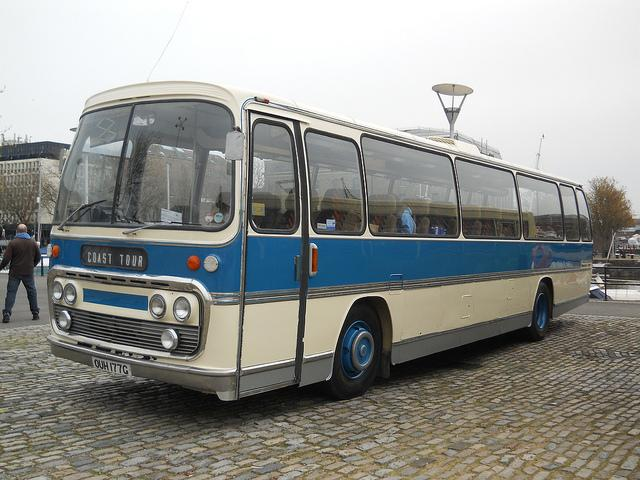What service is being offered for riders on the blue and white bus? coast tour 